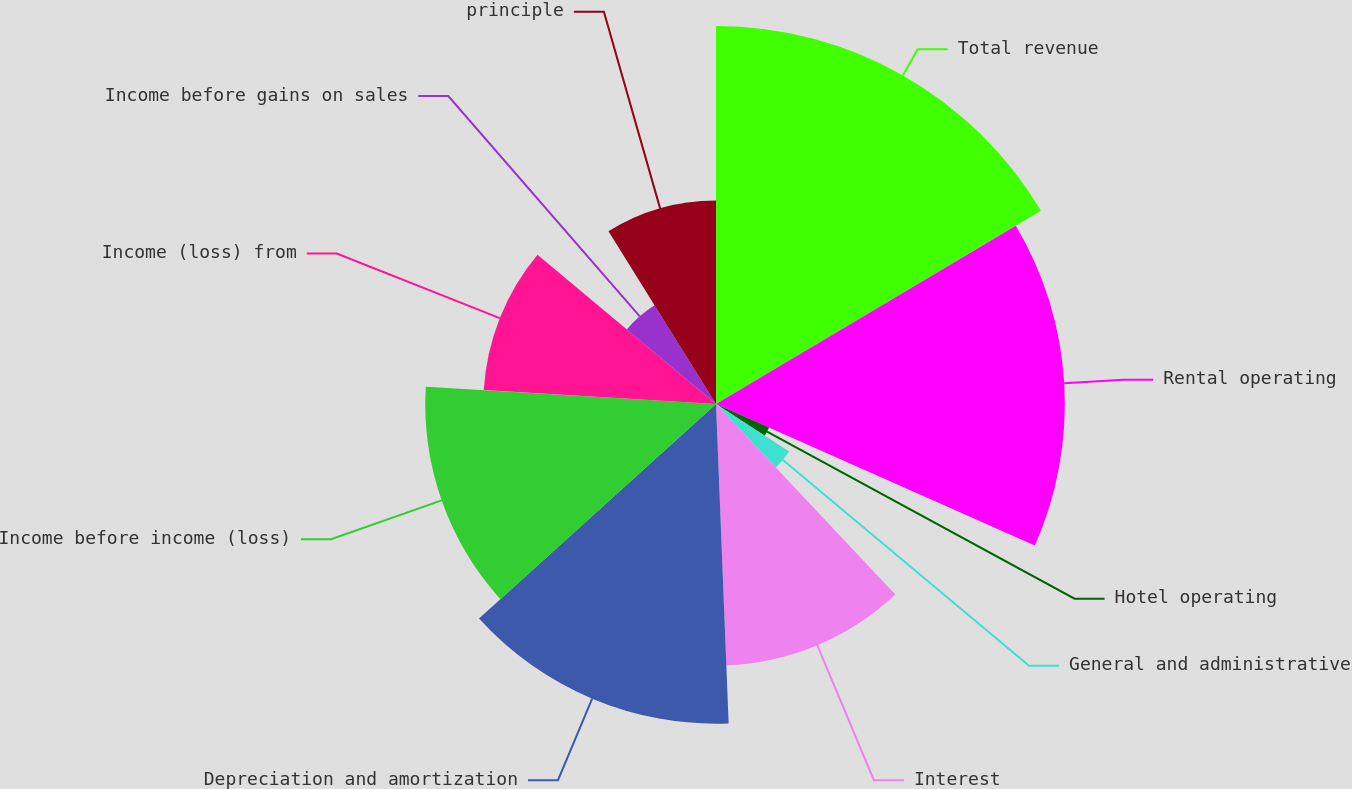Convert chart to OTSL. <chart><loc_0><loc_0><loc_500><loc_500><pie_chart><fcel>Total revenue<fcel>Rental operating<fcel>Hotel operating<fcel>General and administrative<fcel>Interest<fcel>Depreciation and amortization<fcel>Income before income (loss)<fcel>Income (loss) from<fcel>Income before gains on sales<fcel>principle<nl><fcel>16.46%<fcel>15.19%<fcel>2.53%<fcel>3.8%<fcel>11.39%<fcel>13.92%<fcel>12.66%<fcel>10.13%<fcel>5.06%<fcel>8.86%<nl></chart> 